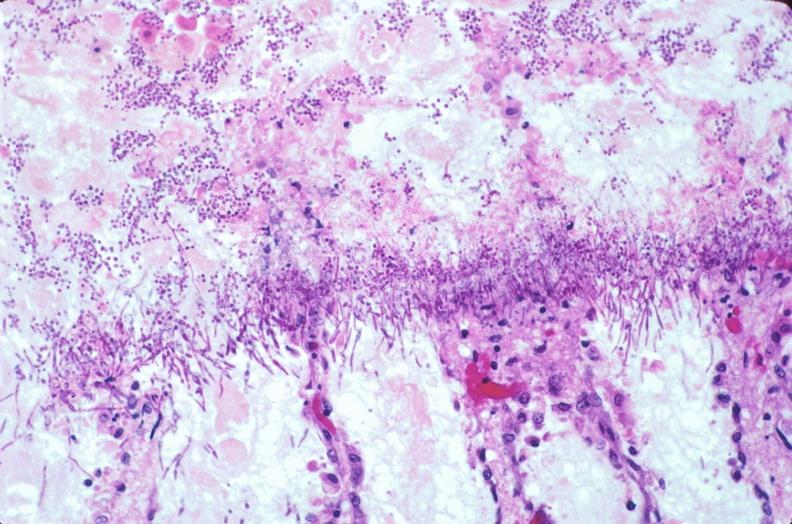does this image show duodenum, necrotizing enteritis with pseudomembrane, candida?
Answer the question using a single word or phrase. Yes 